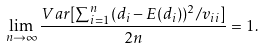Convert formula to latex. <formula><loc_0><loc_0><loc_500><loc_500>\lim _ { n \to \infty } \frac { V a r [ \sum _ { i = 1 } ^ { n } ( d _ { i } - E ( d _ { i } ) ) ^ { 2 } / v _ { i i } ] } { 2 n } = 1 .</formula> 